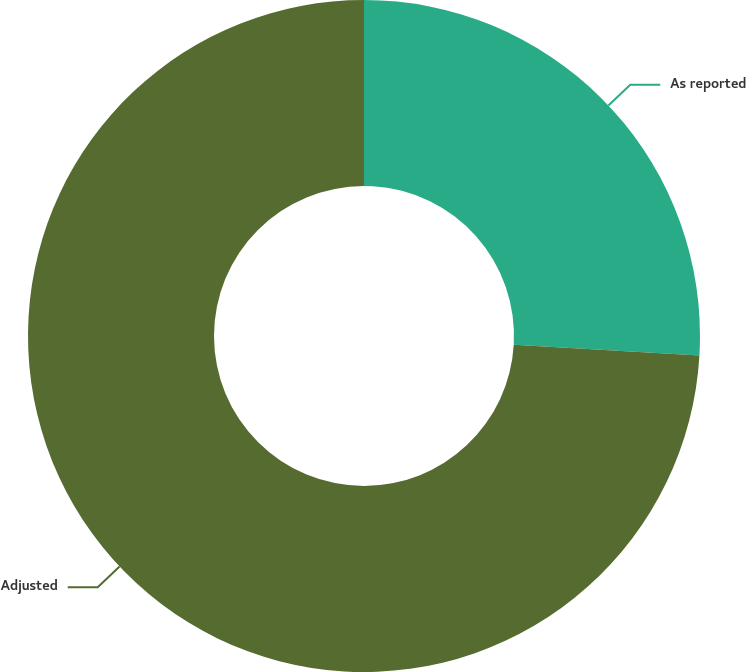<chart> <loc_0><loc_0><loc_500><loc_500><pie_chart><fcel>As reported<fcel>Adjusted<nl><fcel>25.93%<fcel>74.07%<nl></chart> 